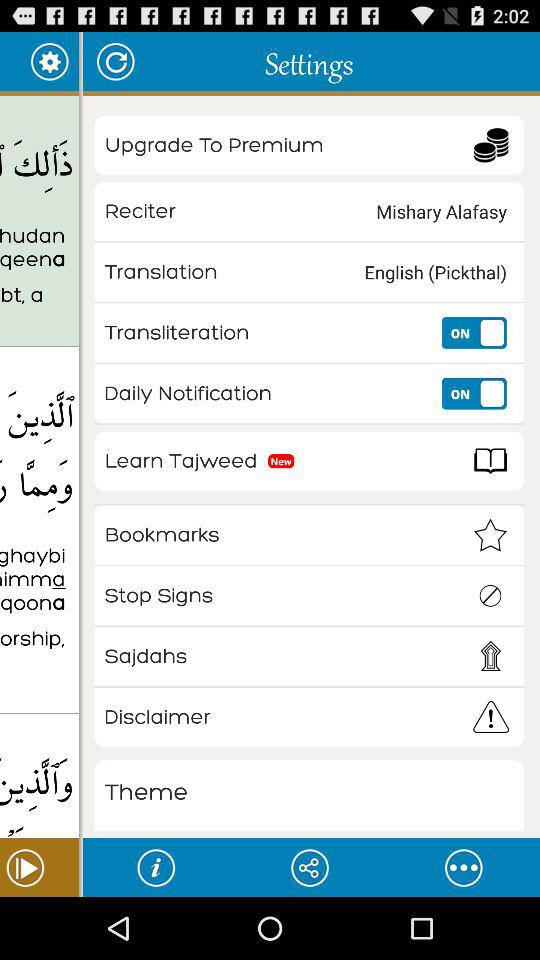What's the "Translation" setting? The "Translation" setting is English (Pickthal). 